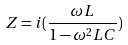<formula> <loc_0><loc_0><loc_500><loc_500>Z = i ( \frac { \omega L } { 1 - \omega ^ { 2 } L C } )</formula> 